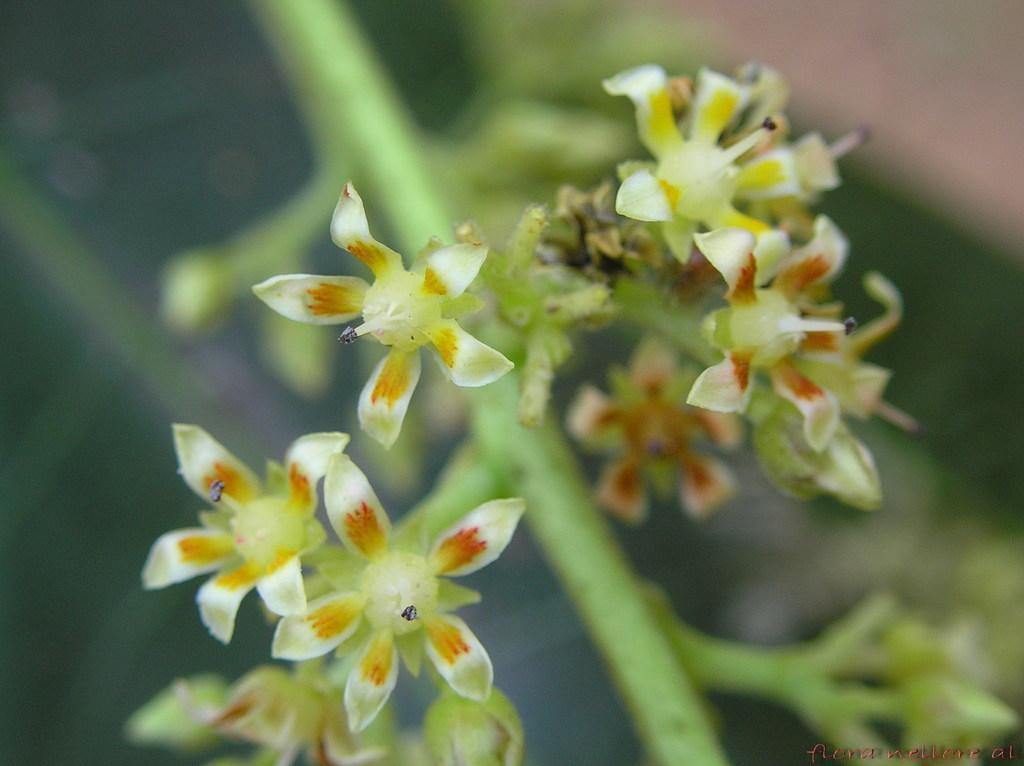What type of plants can be seen in the image? There are flowers in the image. Can you describe any part of the flowers besides the petals? Yes, there are stems of the plants in the image. What type of flame can be seen coming from the pan in the image? There is no pan or flame present in the image; it features flowers and their stems. 